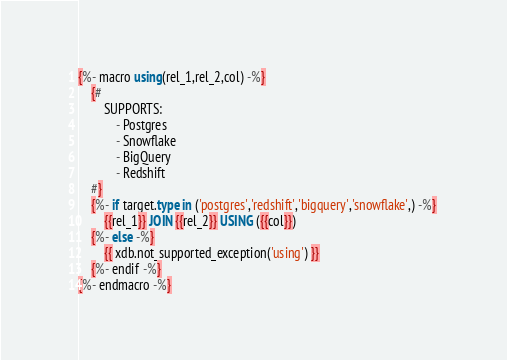Convert code to text. <code><loc_0><loc_0><loc_500><loc_500><_SQL_>{%- macro using(rel_1,rel_2,col) -%}
    {#
        SUPPORTS:
            - Postgres
            - Snowflake
            - BigQuery
            - Redshift
    #}
    {%- if target.type in ('postgres','redshift','bigquery','snowflake',) -%} 
	    {{rel_1}} JOIN {{rel_2}} USING ({{col}})
    {%- else -%}
        {{ xdb.not_supported_exception('using') }}
    {%- endif -%}
{%- endmacro -%}

</code> 